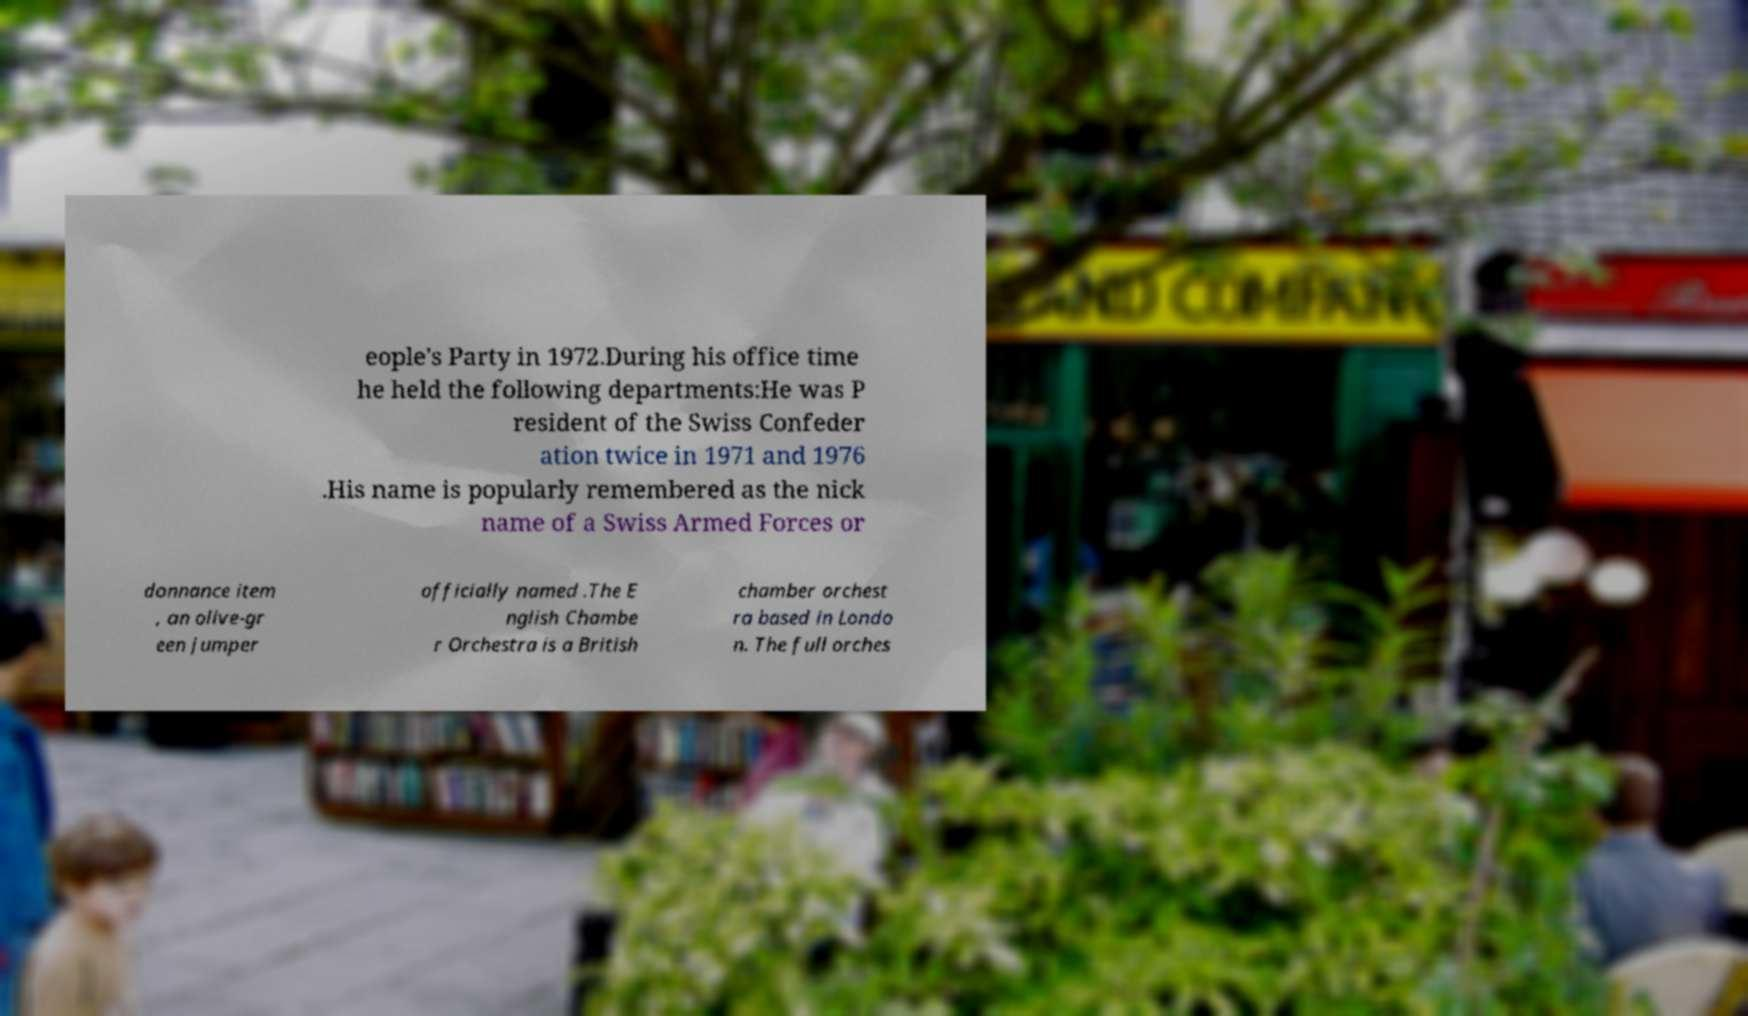Can you read and provide the text displayed in the image?This photo seems to have some interesting text. Can you extract and type it out for me? eople's Party in 1972.During his office time he held the following departments:He was P resident of the Swiss Confeder ation twice in 1971 and 1976 .His name is popularly remembered as the nick name of a Swiss Armed Forces or donnance item , an olive-gr een jumper officially named .The E nglish Chambe r Orchestra is a British chamber orchest ra based in Londo n. The full orches 